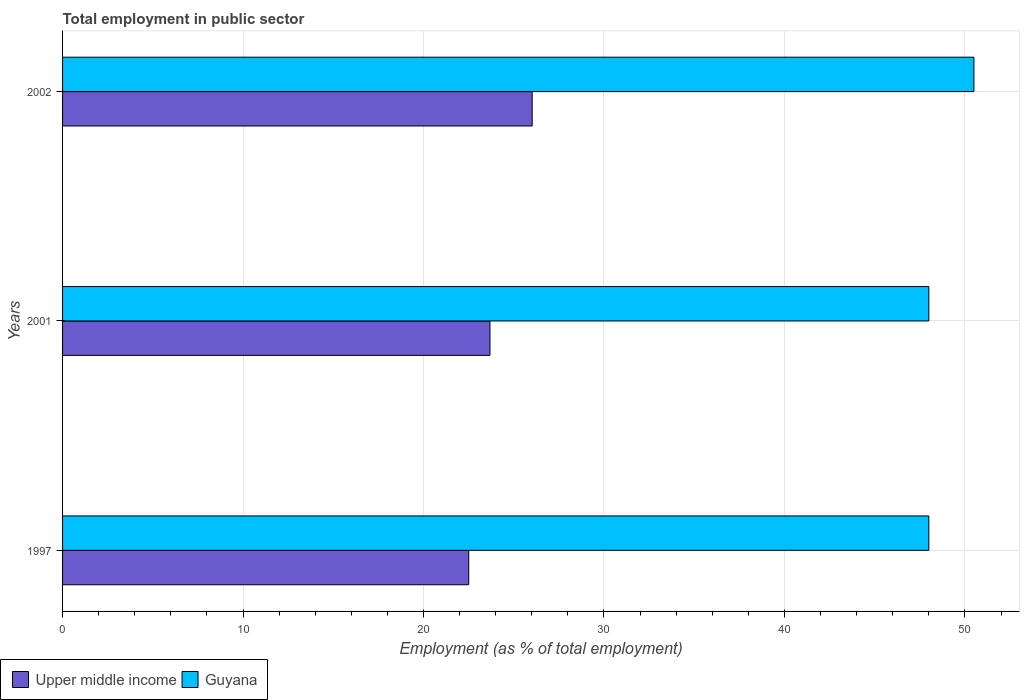What is the label of the 2nd group of bars from the top?
Give a very brief answer. 2001. In how many cases, is the number of bars for a given year not equal to the number of legend labels?
Provide a short and direct response. 0. What is the employment in public sector in Upper middle income in 1997?
Offer a very short reply. 22.51. Across all years, what is the maximum employment in public sector in Upper middle income?
Keep it short and to the point. 26.02. Across all years, what is the minimum employment in public sector in Guyana?
Ensure brevity in your answer.  48. In which year was the employment in public sector in Guyana minimum?
Your response must be concise. 1997. What is the total employment in public sector in Upper middle income in the graph?
Your response must be concise. 72.21. What is the difference between the employment in public sector in Guyana in 1997 and that in 2002?
Keep it short and to the point. -2.5. What is the difference between the employment in public sector in Upper middle income in 1997 and the employment in public sector in Guyana in 2001?
Provide a succinct answer. -25.49. What is the average employment in public sector in Upper middle income per year?
Provide a short and direct response. 24.07. In the year 2001, what is the difference between the employment in public sector in Guyana and employment in public sector in Upper middle income?
Give a very brief answer. 24.32. In how many years, is the employment in public sector in Upper middle income greater than 44 %?
Provide a succinct answer. 0. What is the ratio of the employment in public sector in Upper middle income in 1997 to that in 2002?
Offer a terse response. 0.86. Is the employment in public sector in Upper middle income in 1997 less than that in 2002?
Give a very brief answer. Yes. Is the difference between the employment in public sector in Guyana in 1997 and 2002 greater than the difference between the employment in public sector in Upper middle income in 1997 and 2002?
Offer a very short reply. Yes. What is the difference between the highest and the lowest employment in public sector in Upper middle income?
Ensure brevity in your answer.  3.52. Is the sum of the employment in public sector in Guyana in 1997 and 2002 greater than the maximum employment in public sector in Upper middle income across all years?
Ensure brevity in your answer.  Yes. What does the 2nd bar from the top in 1997 represents?
Provide a short and direct response. Upper middle income. What does the 1st bar from the bottom in 1997 represents?
Provide a short and direct response. Upper middle income. How many bars are there?
Offer a terse response. 6. Are the values on the major ticks of X-axis written in scientific E-notation?
Your answer should be very brief. No. Does the graph contain grids?
Offer a very short reply. Yes. Where does the legend appear in the graph?
Offer a very short reply. Bottom left. What is the title of the graph?
Your response must be concise. Total employment in public sector. Does "Saudi Arabia" appear as one of the legend labels in the graph?
Ensure brevity in your answer.  No. What is the label or title of the X-axis?
Provide a short and direct response. Employment (as % of total employment). What is the label or title of the Y-axis?
Ensure brevity in your answer.  Years. What is the Employment (as % of total employment) in Upper middle income in 1997?
Offer a terse response. 22.51. What is the Employment (as % of total employment) in Upper middle income in 2001?
Offer a terse response. 23.68. What is the Employment (as % of total employment) in Upper middle income in 2002?
Ensure brevity in your answer.  26.02. What is the Employment (as % of total employment) in Guyana in 2002?
Provide a short and direct response. 50.5. Across all years, what is the maximum Employment (as % of total employment) of Upper middle income?
Give a very brief answer. 26.02. Across all years, what is the maximum Employment (as % of total employment) of Guyana?
Make the answer very short. 50.5. Across all years, what is the minimum Employment (as % of total employment) in Upper middle income?
Your answer should be compact. 22.51. What is the total Employment (as % of total employment) of Upper middle income in the graph?
Keep it short and to the point. 72.21. What is the total Employment (as % of total employment) of Guyana in the graph?
Provide a short and direct response. 146.5. What is the difference between the Employment (as % of total employment) in Upper middle income in 1997 and that in 2001?
Keep it short and to the point. -1.18. What is the difference between the Employment (as % of total employment) in Upper middle income in 1997 and that in 2002?
Give a very brief answer. -3.52. What is the difference between the Employment (as % of total employment) in Guyana in 1997 and that in 2002?
Give a very brief answer. -2.5. What is the difference between the Employment (as % of total employment) of Upper middle income in 2001 and that in 2002?
Offer a very short reply. -2.34. What is the difference between the Employment (as % of total employment) in Guyana in 2001 and that in 2002?
Ensure brevity in your answer.  -2.5. What is the difference between the Employment (as % of total employment) of Upper middle income in 1997 and the Employment (as % of total employment) of Guyana in 2001?
Your answer should be very brief. -25.49. What is the difference between the Employment (as % of total employment) of Upper middle income in 1997 and the Employment (as % of total employment) of Guyana in 2002?
Keep it short and to the point. -27.99. What is the difference between the Employment (as % of total employment) of Upper middle income in 2001 and the Employment (as % of total employment) of Guyana in 2002?
Your answer should be compact. -26.82. What is the average Employment (as % of total employment) in Upper middle income per year?
Ensure brevity in your answer.  24.07. What is the average Employment (as % of total employment) in Guyana per year?
Ensure brevity in your answer.  48.83. In the year 1997, what is the difference between the Employment (as % of total employment) in Upper middle income and Employment (as % of total employment) in Guyana?
Your answer should be very brief. -25.49. In the year 2001, what is the difference between the Employment (as % of total employment) of Upper middle income and Employment (as % of total employment) of Guyana?
Offer a very short reply. -24.32. In the year 2002, what is the difference between the Employment (as % of total employment) of Upper middle income and Employment (as % of total employment) of Guyana?
Provide a succinct answer. -24.48. What is the ratio of the Employment (as % of total employment) of Upper middle income in 1997 to that in 2001?
Make the answer very short. 0.95. What is the ratio of the Employment (as % of total employment) in Upper middle income in 1997 to that in 2002?
Make the answer very short. 0.86. What is the ratio of the Employment (as % of total employment) in Guyana in 1997 to that in 2002?
Provide a short and direct response. 0.95. What is the ratio of the Employment (as % of total employment) in Upper middle income in 2001 to that in 2002?
Provide a short and direct response. 0.91. What is the ratio of the Employment (as % of total employment) in Guyana in 2001 to that in 2002?
Ensure brevity in your answer.  0.95. What is the difference between the highest and the second highest Employment (as % of total employment) of Upper middle income?
Provide a short and direct response. 2.34. What is the difference between the highest and the lowest Employment (as % of total employment) of Upper middle income?
Your answer should be compact. 3.52. 